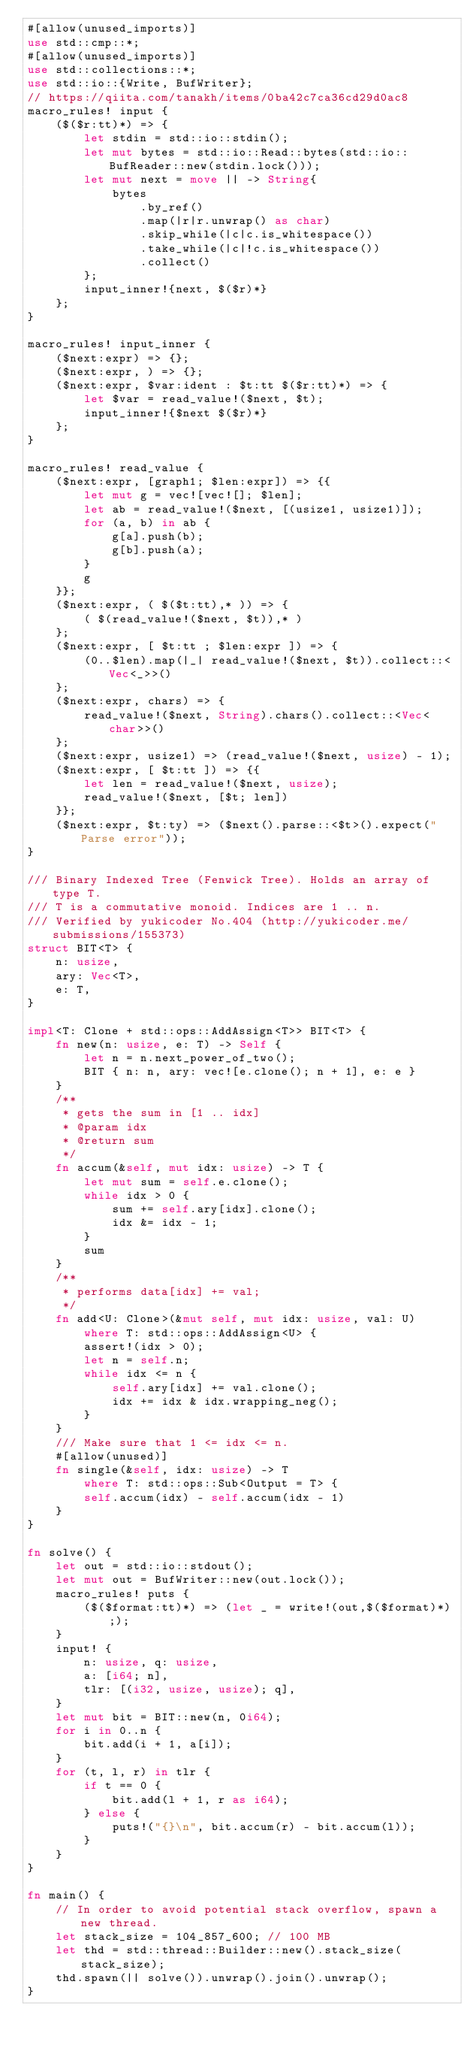<code> <loc_0><loc_0><loc_500><loc_500><_Rust_>#[allow(unused_imports)]
use std::cmp::*;
#[allow(unused_imports)]
use std::collections::*;
use std::io::{Write, BufWriter};
// https://qiita.com/tanakh/items/0ba42c7ca36cd29d0ac8
macro_rules! input {
    ($($r:tt)*) => {
        let stdin = std::io::stdin();
        let mut bytes = std::io::Read::bytes(std::io::BufReader::new(stdin.lock()));
        let mut next = move || -> String{
            bytes
                .by_ref()
                .map(|r|r.unwrap() as char)
                .skip_while(|c|c.is_whitespace())
                .take_while(|c|!c.is_whitespace())
                .collect()
        };
        input_inner!{next, $($r)*}
    };
}

macro_rules! input_inner {
    ($next:expr) => {};
    ($next:expr, ) => {};
    ($next:expr, $var:ident : $t:tt $($r:tt)*) => {
        let $var = read_value!($next, $t);
        input_inner!{$next $($r)*}
    };
}

macro_rules! read_value {
    ($next:expr, [graph1; $len:expr]) => {{
        let mut g = vec![vec![]; $len];
        let ab = read_value!($next, [(usize1, usize1)]);
        for (a, b) in ab {
            g[a].push(b);
            g[b].push(a);
        }
        g
    }};
    ($next:expr, ( $($t:tt),* )) => {
        ( $(read_value!($next, $t)),* )
    };
    ($next:expr, [ $t:tt ; $len:expr ]) => {
        (0..$len).map(|_| read_value!($next, $t)).collect::<Vec<_>>()
    };
    ($next:expr, chars) => {
        read_value!($next, String).chars().collect::<Vec<char>>()
    };
    ($next:expr, usize1) => (read_value!($next, usize) - 1);
    ($next:expr, [ $t:tt ]) => {{
        let len = read_value!($next, usize);
        read_value!($next, [$t; len])
    }};
    ($next:expr, $t:ty) => ($next().parse::<$t>().expect("Parse error"));
}

/// Binary Indexed Tree (Fenwick Tree). Holds an array of type T.
/// T is a commutative monoid. Indices are 1 .. n.
/// Verified by yukicoder No.404 (http://yukicoder.me/submissions/155373)
struct BIT<T> {
    n: usize,
    ary: Vec<T>,
    e: T,
}

impl<T: Clone + std::ops::AddAssign<T>> BIT<T> {
    fn new(n: usize, e: T) -> Self {
        let n = n.next_power_of_two();
        BIT { n: n, ary: vec![e.clone(); n + 1], e: e }
    }
    /**
     * gets the sum in [1 .. idx]
     * @param idx
     * @return sum
     */
    fn accum(&self, mut idx: usize) -> T {
        let mut sum = self.e.clone();
        while idx > 0 {
            sum += self.ary[idx].clone();
            idx &= idx - 1;
        }
        sum
    }
    /**
     * performs data[idx] += val;
     */
    fn add<U: Clone>(&mut self, mut idx: usize, val: U)
        where T: std::ops::AddAssign<U> {
        assert!(idx > 0);
        let n = self.n;
        while idx <= n {
            self.ary[idx] += val.clone();
            idx += idx & idx.wrapping_neg();
        }
    }
    /// Make sure that 1 <= idx <= n.
    #[allow(unused)]
    fn single(&self, idx: usize) -> T
        where T: std::ops::Sub<Output = T> {
        self.accum(idx) - self.accum(idx - 1)
    }
}

fn solve() {
    let out = std::io::stdout();
    let mut out = BufWriter::new(out.lock());
    macro_rules! puts {
        ($($format:tt)*) => (let _ = write!(out,$($format)*););
    }
    input! {
        n: usize, q: usize,
        a: [i64; n],
        tlr: [(i32, usize, usize); q],
    }
    let mut bit = BIT::new(n, 0i64);
    for i in 0..n {
        bit.add(i + 1, a[i]);
    }
    for (t, l, r) in tlr {
        if t == 0 {
            bit.add(l + 1, r as i64);
        } else {
            puts!("{}\n", bit.accum(r) - bit.accum(l));
        }
    }
}

fn main() {
    // In order to avoid potential stack overflow, spawn a new thread.
    let stack_size = 104_857_600; // 100 MB
    let thd = std::thread::Builder::new().stack_size(stack_size);
    thd.spawn(|| solve()).unwrap().join().unwrap();
}
</code> 